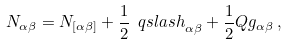Convert formula to latex. <formula><loc_0><loc_0><loc_500><loc_500>N _ { \alpha \beta } = N _ { [ \alpha \beta ] } + \frac { 1 } { 2 } { \ q s l a s h } _ { \alpha \beta } + \frac { 1 } { 2 } Q g _ { \alpha \beta } \, ,</formula> 